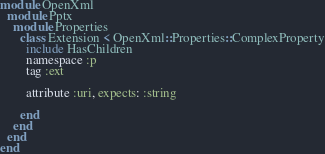<code> <loc_0><loc_0><loc_500><loc_500><_Ruby_>module OpenXml
  module Pptx
    module Properties
      class Extension < OpenXml::Properties::ComplexProperty
        include HasChildren
        namespace :p
        tag :ext

        attribute :uri, expects: :string

      end
    end
  end
end
</code> 